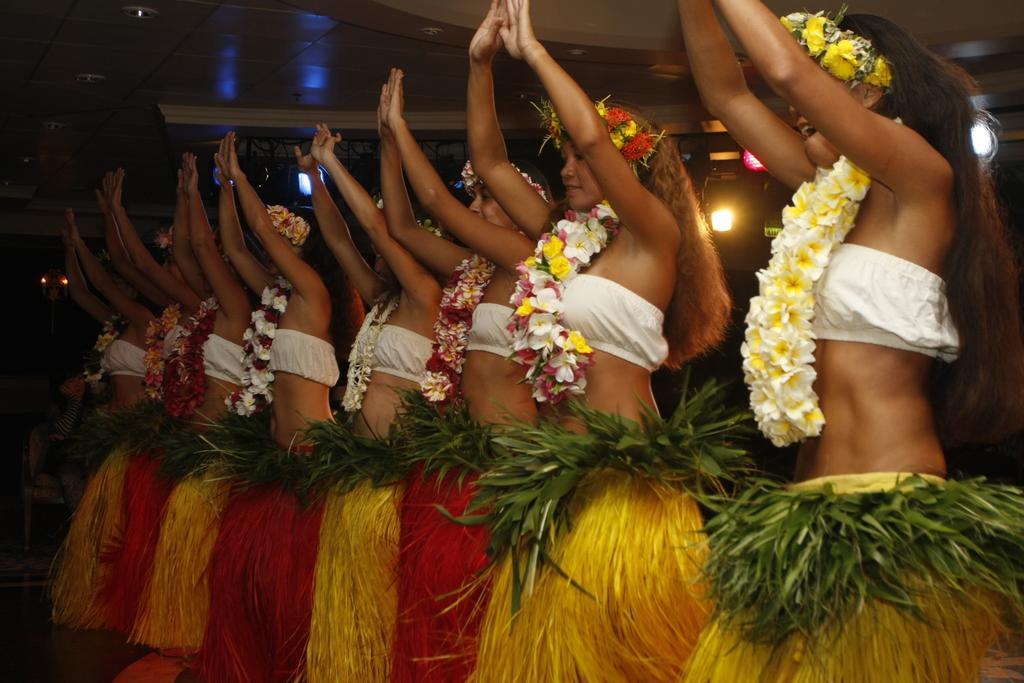Can you describe this image briefly? In this image we can see women wearing costumes and standing on the floor in a row. In the background we can see iron grills, electric lights and a person sitting on the chair. 